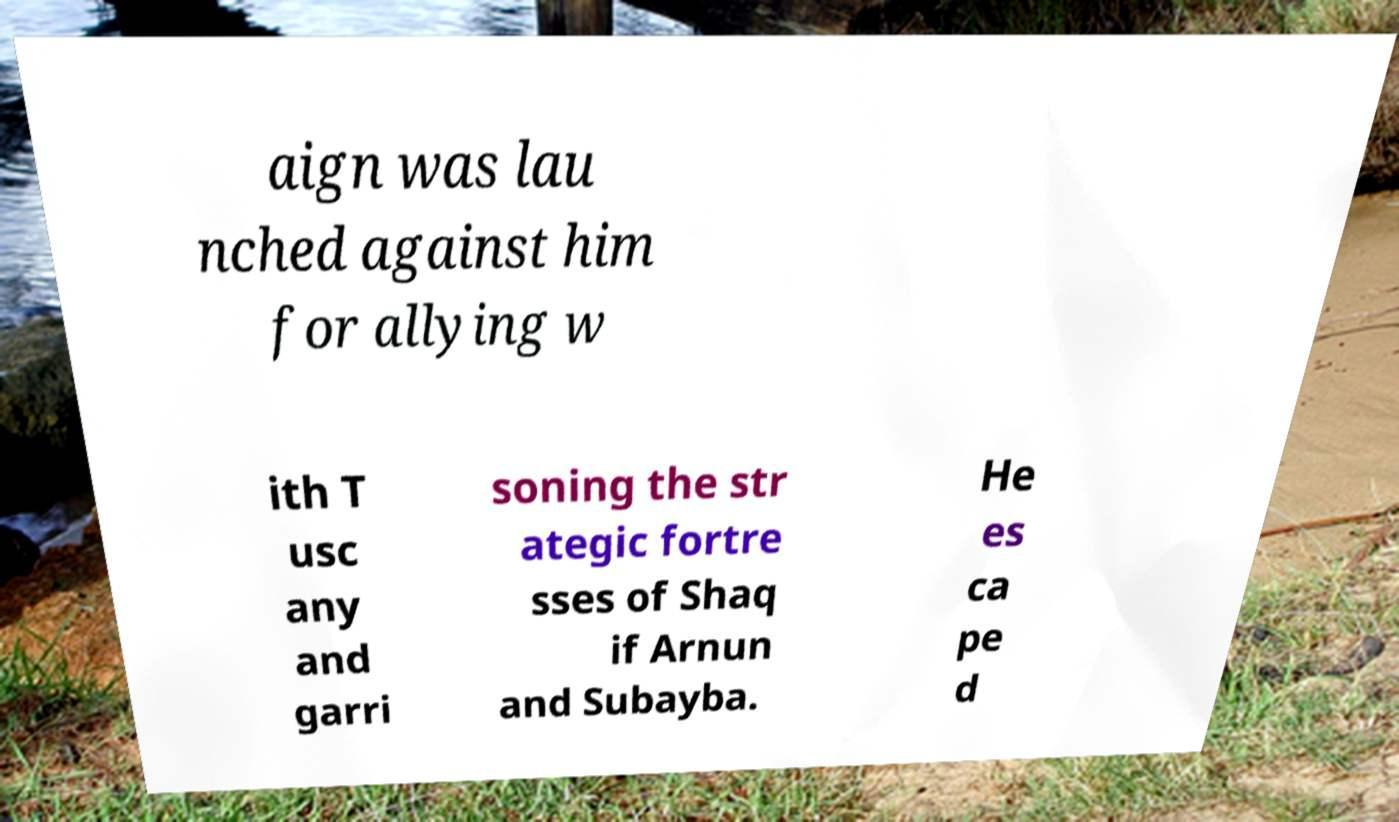I need the written content from this picture converted into text. Can you do that? aign was lau nched against him for allying w ith T usc any and garri soning the str ategic fortre sses of Shaq if Arnun and Subayba. He es ca pe d 